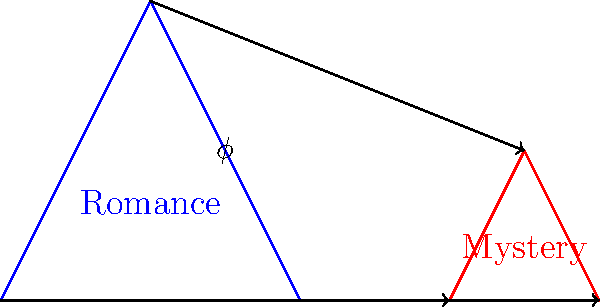Consider the homomorphism $\phi$ from the group of Romance writing styles to the group of Mystery writing styles, as shown in the diagram. If the identity element in the Romance group represents "classic romance," and $\phi$ maps it to "cozy mystery" in the Mystery group, what can we conclude about the kernel of $\phi$? Let's approach this step-by-step:

1) In group theory, a homomorphism $\phi: G \to H$ is a function between two groups that preserves the group operation.

2) The kernel of a homomorphism $\phi$, denoted as $\ker(\phi)$, is the set of all elements in the domain that map to the identity element in the codomain.

3) In this case, we're told that the identity element of the Romance group (let's call it $e_R$) is "classic romance," and it maps to "cozy mystery" in the Mystery group.

4) However, "cozy mystery" is not necessarily the identity element of the Mystery group (let's call the identity of the Mystery group $e_M$).

5) For a homomorphism to be injective (one-to-one), its kernel must contain only the identity element of the domain.

6) Since $\phi(e_R) \neq e_M$ (assuming "cozy mystery" is not the identity in the Mystery group), we can conclude that the kernel of $\phi$ is not trivial.

7) This means that there are elements other than the identity in the Romance group that map to "cozy mystery" in the Mystery group.

Therefore, we can conclude that the kernel of $\phi$ is non-trivial, meaning it contains elements other than just the identity element of the Romance group.
Answer: The kernel of $\phi$ is non-trivial. 